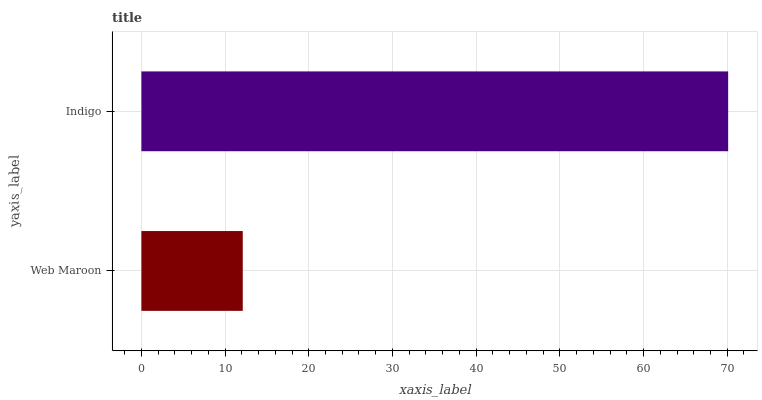Is Web Maroon the minimum?
Answer yes or no. Yes. Is Indigo the maximum?
Answer yes or no. Yes. Is Indigo the minimum?
Answer yes or no. No. Is Indigo greater than Web Maroon?
Answer yes or no. Yes. Is Web Maroon less than Indigo?
Answer yes or no. Yes. Is Web Maroon greater than Indigo?
Answer yes or no. No. Is Indigo less than Web Maroon?
Answer yes or no. No. Is Indigo the high median?
Answer yes or no. Yes. Is Web Maroon the low median?
Answer yes or no. Yes. Is Web Maroon the high median?
Answer yes or no. No. Is Indigo the low median?
Answer yes or no. No. 